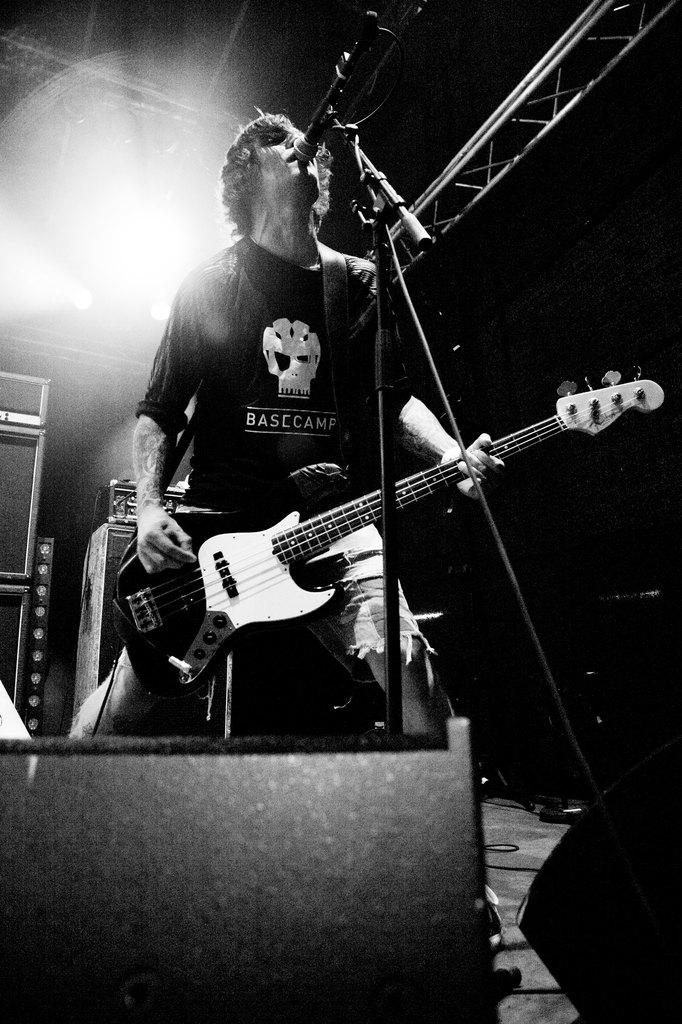What is the man doing on stage in the image? The man is playing a guitar and singing into a microphone. What instrument is the man playing? The man is playing a guitar. Can you describe the man's position on stage? The man is standing on stage. What is present behind the man on stage? There is an iron rod behind the man. What type of hill can be seen in the background of the image? There is no hill visible in the image; it features a man on stage playing a guitar and singing into a microphone. 